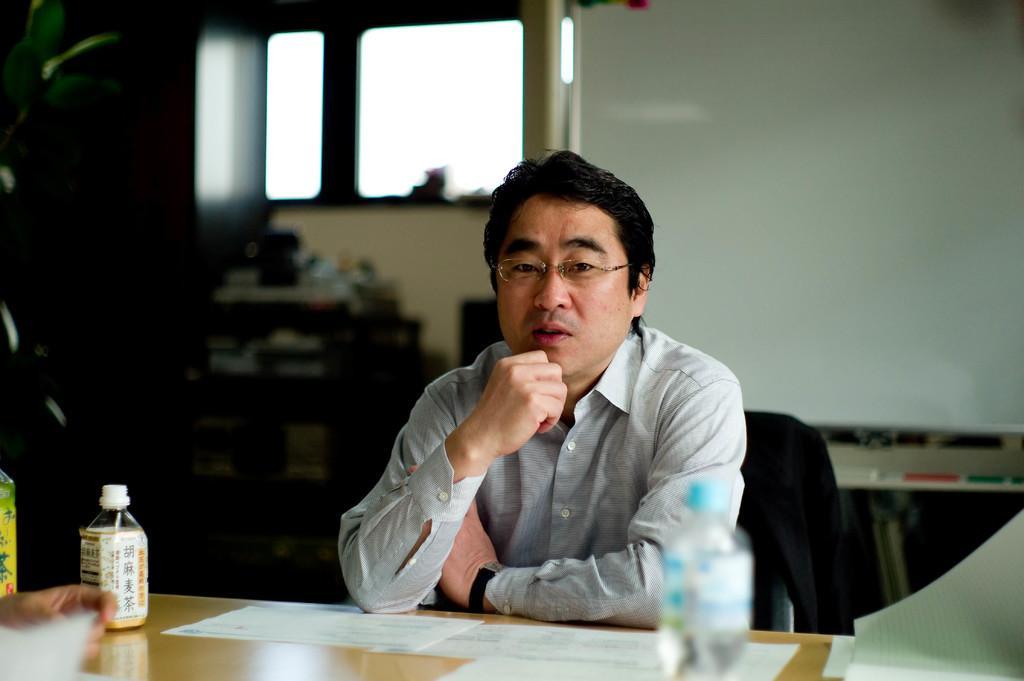Please provide a concise description of this image. A man is sitting on the chair placed his hands on the table. There are few bottles and papers on the table. In the background we can see window and a screen. 